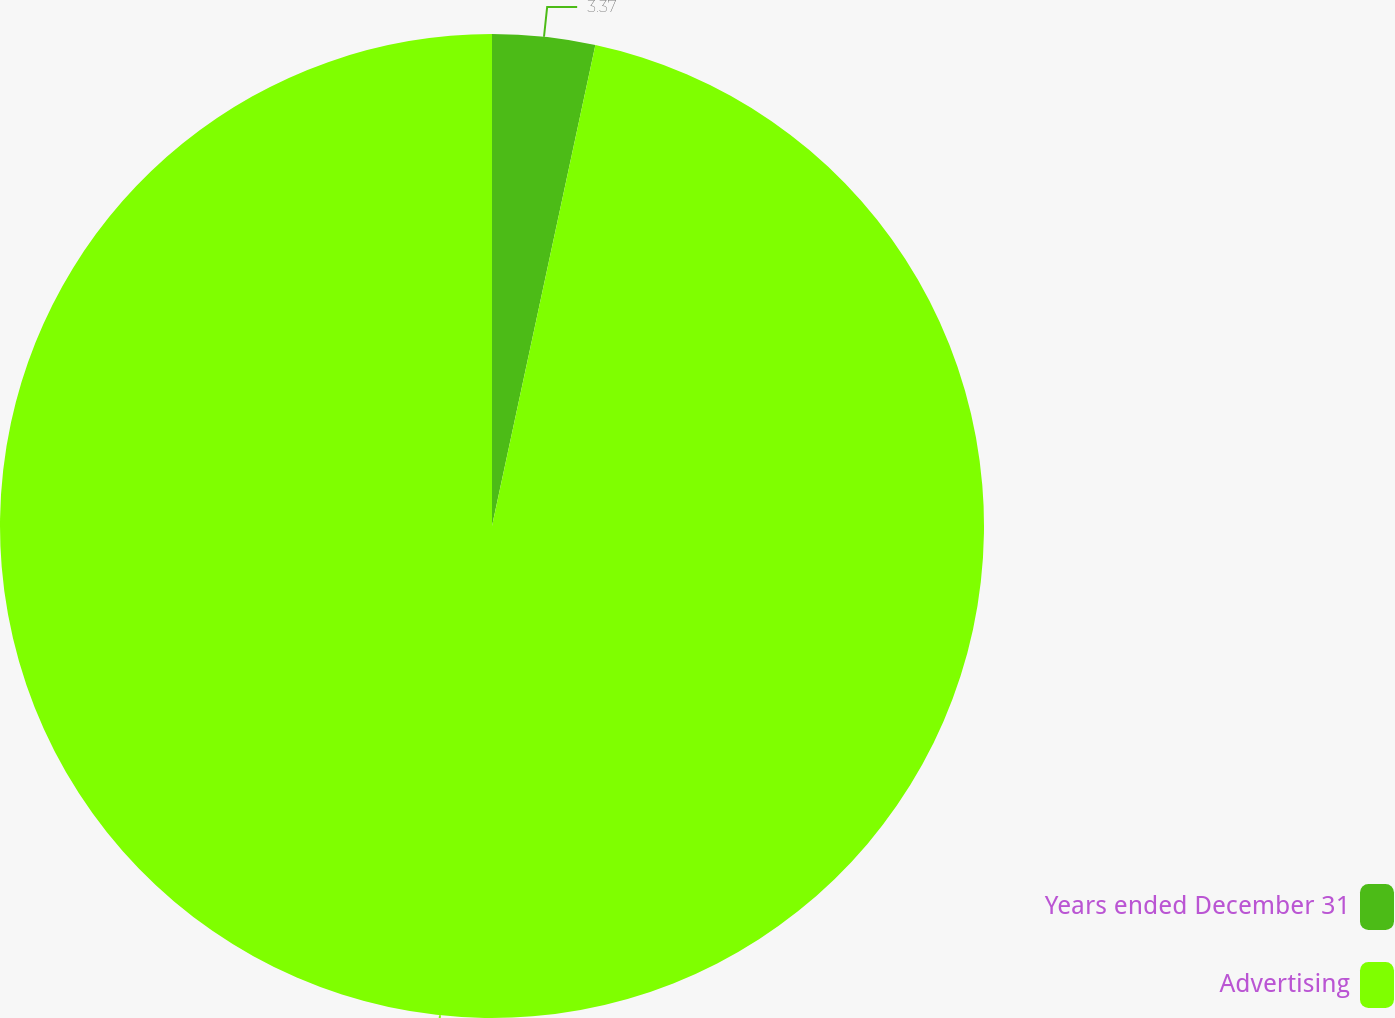Convert chart. <chart><loc_0><loc_0><loc_500><loc_500><pie_chart><fcel>Years ended December 31<fcel>Advertising<nl><fcel>3.37%<fcel>96.63%<nl></chart> 